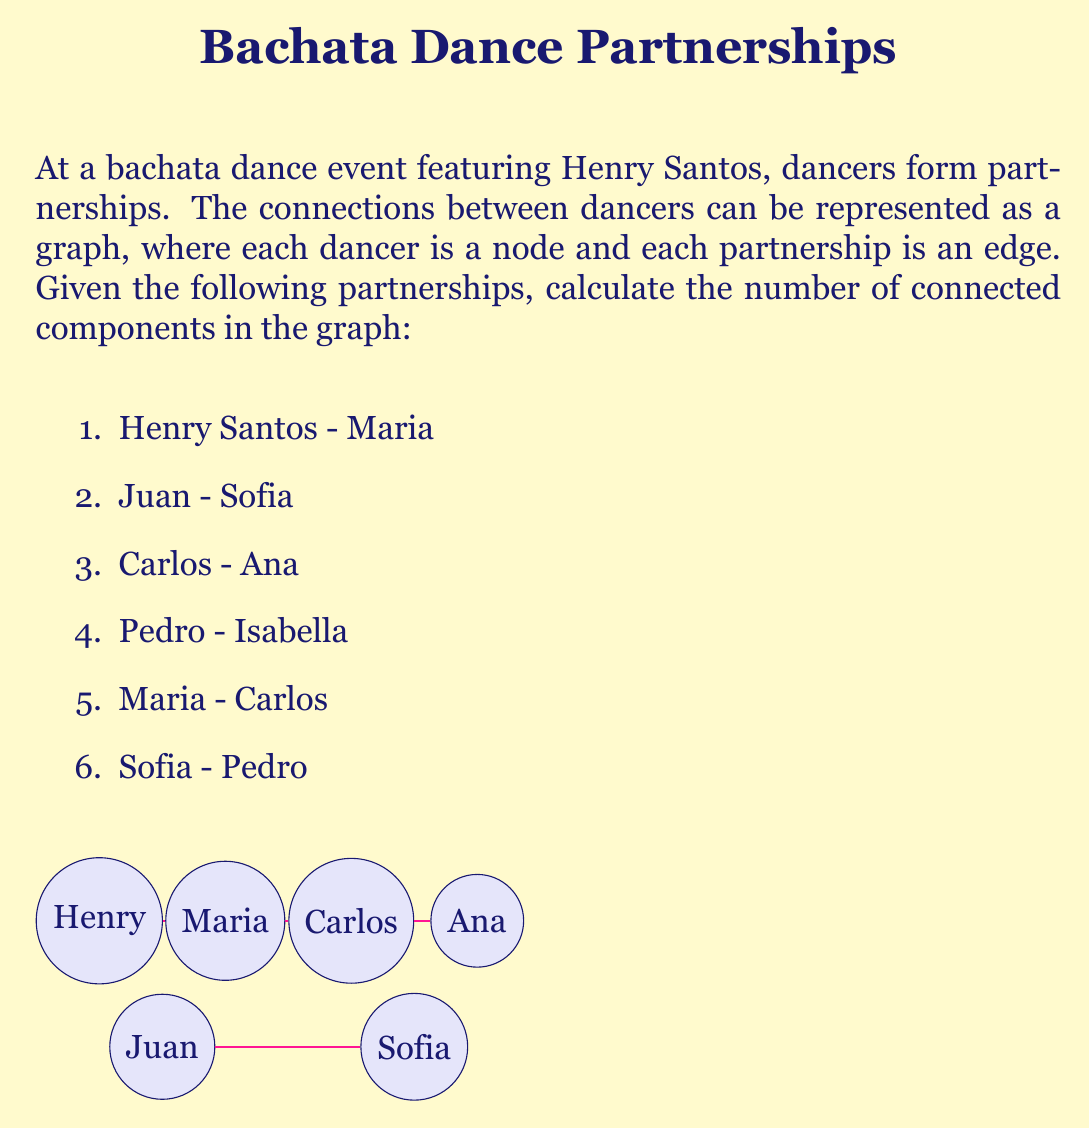Give your solution to this math problem. To solve this problem, we need to identify the connected components in the graph representing the bachata dance partnerships. A connected component is a subgraph in which any two vertices are connected to each other by paths.

Let's analyze the partnerships:

1. Henry Santos, Maria, Carlos, and Ana form one connected component:
   - Henry Santos is connected to Maria
   - Maria is connected to Carlos
   - Carlos is connected to Ana

2. Juan and Sofia form another connected component:
   - Juan is connected to Sofia

3. Pedro and Isabella form a third connected component:
   - Pedro is connected to Isabella

To count the number of connected components:

1. Component 1: {Henry Santos, Maria, Carlos, Ana}
2. Component 2: {Juan, Sofia}
3. Component 3: {Pedro, Isabella}

Therefore, there are 3 connected components in this graph.

It's worth noting that in the context of bachata dancing, each connected component represents a group of dancers who are indirectly connected through partnerships. Henry Santos, being the featured artist, is part of the largest connected component in this scenario.
Answer: The number of connected components in the graph is 3. 